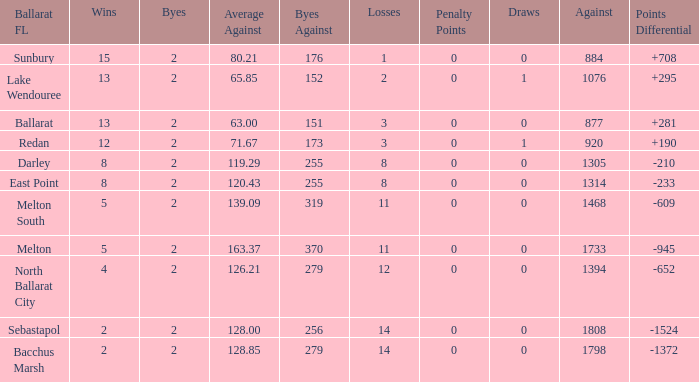How many Against has Byes smaller than 2? None. 